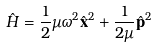Convert formula to latex. <formula><loc_0><loc_0><loc_500><loc_500>\hat { H } = \frac { 1 } { 2 } \mu \omega ^ { 2 } \hat { \mathbf x } ^ { 2 } + \frac { 1 } { 2 \mu } \hat { \mathbf p } ^ { 2 }</formula> 